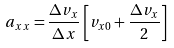<formula> <loc_0><loc_0><loc_500><loc_500>a _ { x x } = \frac { \Delta v _ { x } } { \Delta x } \left [ v _ { x 0 } + \frac { \Delta v _ { x } } { 2 } \right ]</formula> 